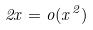<formula> <loc_0><loc_0><loc_500><loc_500>2 x = o ( x ^ { 2 } )</formula> 